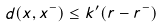<formula> <loc_0><loc_0><loc_500><loc_500>d ( x , x ^ { - } ) \leq k ^ { \prime } ( r - r ^ { - } )</formula> 